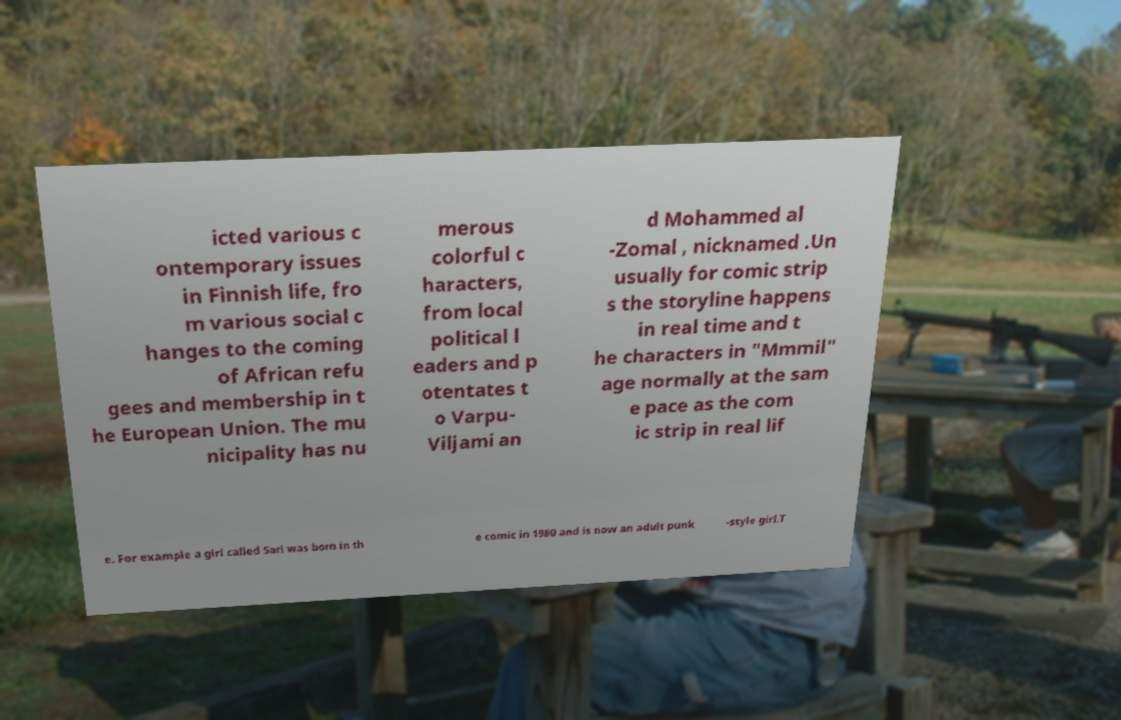There's text embedded in this image that I need extracted. Can you transcribe it verbatim? icted various c ontemporary issues in Finnish life, fro m various social c hanges to the coming of African refu gees and membership in t he European Union. The mu nicipality has nu merous colorful c haracters, from local political l eaders and p otentates t o Varpu- Viljami an d Mohammed al -Zomal , nicknamed .Un usually for comic strip s the storyline happens in real time and t he characters in "Mmmil" age normally at the sam e pace as the com ic strip in real lif e. For example a girl called Sari was born in th e comic in 1980 and is now an adult punk -style girl.T 